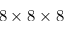<formula> <loc_0><loc_0><loc_500><loc_500>8 \times 8 \times 8</formula> 